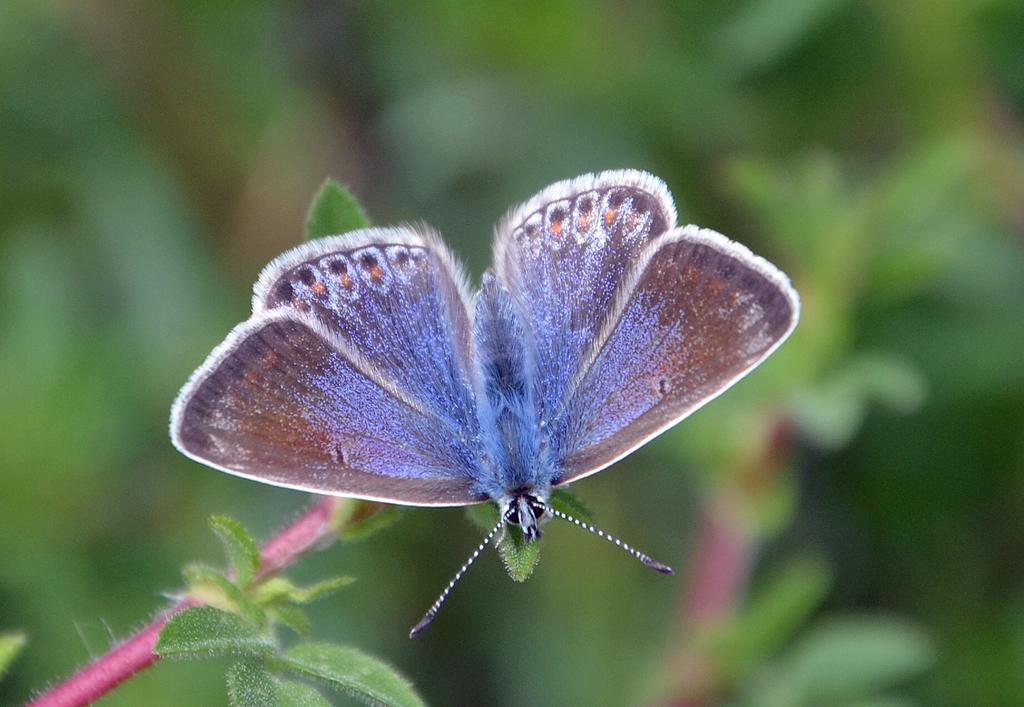How would you summarize this image in a sentence or two? There is a butterfly in the foreground area of the image on a leaf and the background is blurry. 